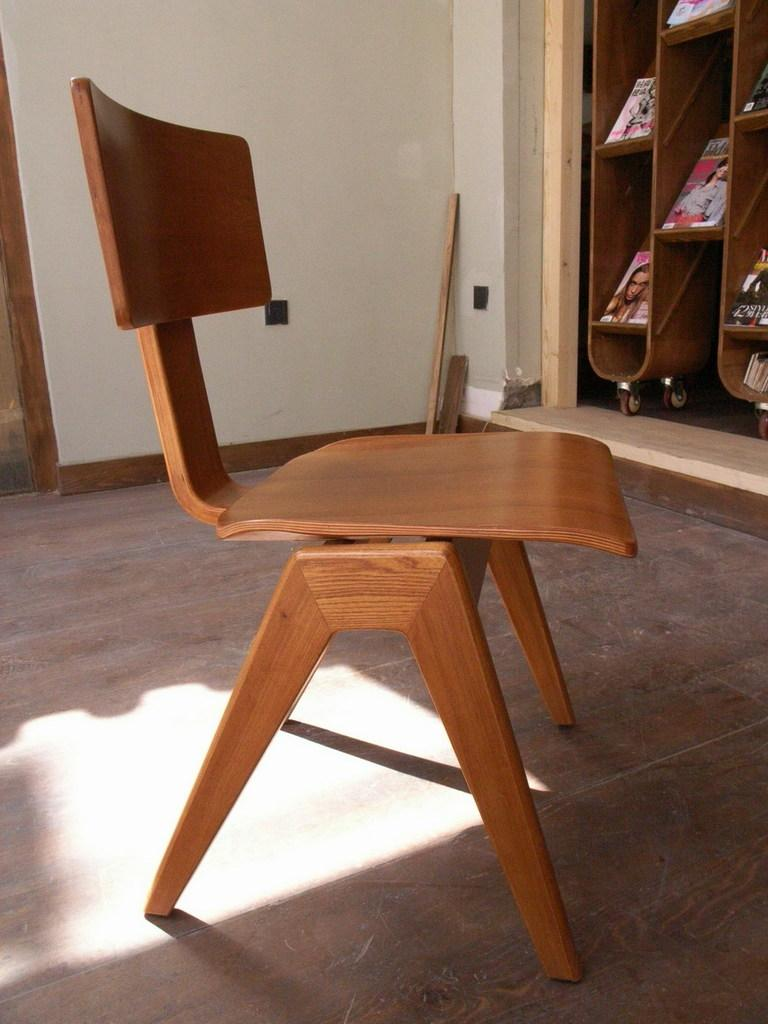What is located in the center of the image? There is a chair in the center of the image. What can be seen on the right side of the image? There is a rack on the right side of the image. What is stored in the rack? There are books placed in the rack. What is visible in the background of the image? There is a wall and sticks visible in the background. What type of operation is being performed on the chair in the image? There is no operation being performed on the chair in the image; it is simply a chair placed in the center. 